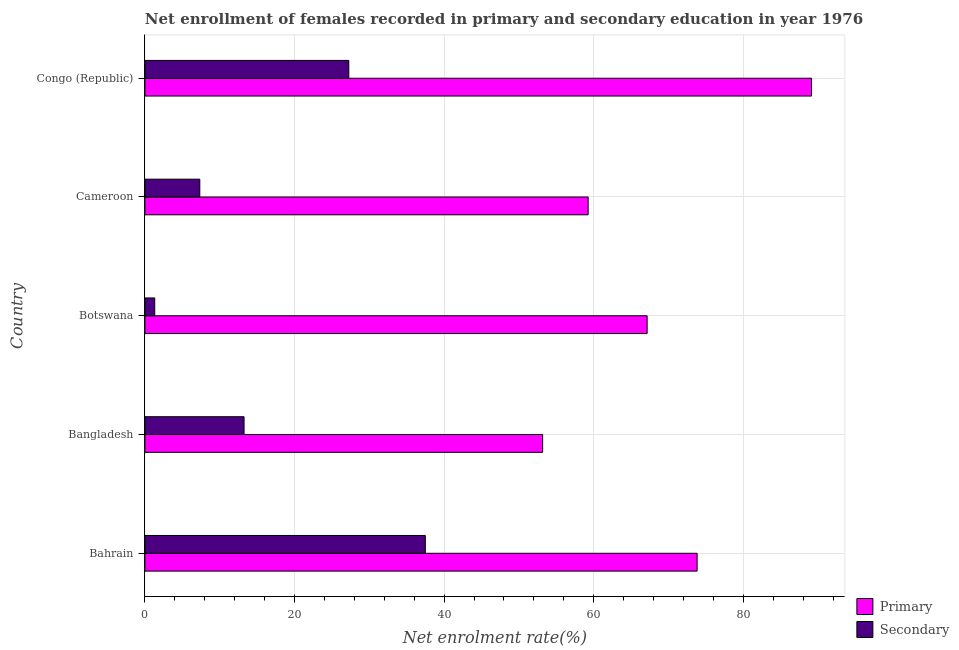How many groups of bars are there?
Offer a terse response. 5. How many bars are there on the 3rd tick from the top?
Your answer should be compact. 2. How many bars are there on the 4th tick from the bottom?
Your answer should be compact. 2. What is the label of the 4th group of bars from the top?
Offer a terse response. Bangladesh. What is the enrollment rate in primary education in Cameroon?
Offer a terse response. 59.25. Across all countries, what is the maximum enrollment rate in primary education?
Give a very brief answer. 89.11. Across all countries, what is the minimum enrollment rate in secondary education?
Offer a terse response. 1.31. In which country was the enrollment rate in secondary education maximum?
Offer a very short reply. Bahrain. In which country was the enrollment rate in secondary education minimum?
Offer a very short reply. Botswana. What is the total enrollment rate in secondary education in the graph?
Provide a succinct answer. 86.64. What is the difference between the enrollment rate in primary education in Bangladesh and that in Cameroon?
Provide a short and direct response. -6.08. What is the difference between the enrollment rate in primary education in Bangladesh and the enrollment rate in secondary education in Cameroon?
Make the answer very short. 45.83. What is the average enrollment rate in secondary education per country?
Keep it short and to the point. 17.33. What is the difference between the enrollment rate in secondary education and enrollment rate in primary education in Congo (Republic)?
Ensure brevity in your answer.  -61.86. In how many countries, is the enrollment rate in secondary education greater than 56 %?
Your answer should be very brief. 0. What is the ratio of the enrollment rate in primary education in Bahrain to that in Congo (Republic)?
Provide a succinct answer. 0.83. What is the difference between the highest and the second highest enrollment rate in secondary education?
Your answer should be very brief. 10.23. What is the difference between the highest and the lowest enrollment rate in primary education?
Make the answer very short. 35.95. In how many countries, is the enrollment rate in secondary education greater than the average enrollment rate in secondary education taken over all countries?
Your answer should be very brief. 2. Is the sum of the enrollment rate in primary education in Bahrain and Botswana greater than the maximum enrollment rate in secondary education across all countries?
Your answer should be very brief. Yes. What does the 1st bar from the top in Bangladesh represents?
Make the answer very short. Secondary. What does the 2nd bar from the bottom in Bahrain represents?
Your response must be concise. Secondary. How many bars are there?
Your answer should be compact. 10. How many countries are there in the graph?
Offer a very short reply. 5. What is the difference between two consecutive major ticks on the X-axis?
Your response must be concise. 20. Are the values on the major ticks of X-axis written in scientific E-notation?
Keep it short and to the point. No. Does the graph contain grids?
Your answer should be very brief. Yes. Where does the legend appear in the graph?
Give a very brief answer. Bottom right. How many legend labels are there?
Your answer should be very brief. 2. What is the title of the graph?
Keep it short and to the point. Net enrollment of females recorded in primary and secondary education in year 1976. Does "Drinking water services" appear as one of the legend labels in the graph?
Ensure brevity in your answer.  No. What is the label or title of the X-axis?
Offer a very short reply. Net enrolment rate(%). What is the label or title of the Y-axis?
Make the answer very short. Country. What is the Net enrolment rate(%) in Primary in Bahrain?
Offer a very short reply. 73.82. What is the Net enrolment rate(%) in Secondary in Bahrain?
Give a very brief answer. 37.48. What is the Net enrolment rate(%) of Primary in Bangladesh?
Your answer should be compact. 53.17. What is the Net enrolment rate(%) of Secondary in Bangladesh?
Ensure brevity in your answer.  13.25. What is the Net enrolment rate(%) of Primary in Botswana?
Offer a terse response. 67.14. What is the Net enrolment rate(%) in Secondary in Botswana?
Provide a short and direct response. 1.31. What is the Net enrolment rate(%) in Primary in Cameroon?
Your response must be concise. 59.25. What is the Net enrolment rate(%) of Secondary in Cameroon?
Your answer should be very brief. 7.34. What is the Net enrolment rate(%) of Primary in Congo (Republic)?
Your answer should be very brief. 89.11. What is the Net enrolment rate(%) in Secondary in Congo (Republic)?
Provide a succinct answer. 27.25. Across all countries, what is the maximum Net enrolment rate(%) of Primary?
Ensure brevity in your answer.  89.11. Across all countries, what is the maximum Net enrolment rate(%) in Secondary?
Make the answer very short. 37.48. Across all countries, what is the minimum Net enrolment rate(%) in Primary?
Give a very brief answer. 53.17. Across all countries, what is the minimum Net enrolment rate(%) of Secondary?
Make the answer very short. 1.31. What is the total Net enrolment rate(%) of Primary in the graph?
Your answer should be compact. 342.48. What is the total Net enrolment rate(%) of Secondary in the graph?
Your response must be concise. 86.64. What is the difference between the Net enrolment rate(%) in Primary in Bahrain and that in Bangladesh?
Offer a very short reply. 20.65. What is the difference between the Net enrolment rate(%) in Secondary in Bahrain and that in Bangladesh?
Provide a succinct answer. 24.23. What is the difference between the Net enrolment rate(%) of Primary in Bahrain and that in Botswana?
Make the answer very short. 6.68. What is the difference between the Net enrolment rate(%) of Secondary in Bahrain and that in Botswana?
Your answer should be very brief. 36.17. What is the difference between the Net enrolment rate(%) in Primary in Bahrain and that in Cameroon?
Keep it short and to the point. 14.57. What is the difference between the Net enrolment rate(%) of Secondary in Bahrain and that in Cameroon?
Your answer should be compact. 30.15. What is the difference between the Net enrolment rate(%) of Primary in Bahrain and that in Congo (Republic)?
Keep it short and to the point. -15.29. What is the difference between the Net enrolment rate(%) in Secondary in Bahrain and that in Congo (Republic)?
Ensure brevity in your answer.  10.23. What is the difference between the Net enrolment rate(%) of Primary in Bangladesh and that in Botswana?
Offer a terse response. -13.97. What is the difference between the Net enrolment rate(%) of Secondary in Bangladesh and that in Botswana?
Offer a terse response. 11.94. What is the difference between the Net enrolment rate(%) in Primary in Bangladesh and that in Cameroon?
Ensure brevity in your answer.  -6.08. What is the difference between the Net enrolment rate(%) of Secondary in Bangladesh and that in Cameroon?
Keep it short and to the point. 5.92. What is the difference between the Net enrolment rate(%) of Primary in Bangladesh and that in Congo (Republic)?
Give a very brief answer. -35.95. What is the difference between the Net enrolment rate(%) in Secondary in Bangladesh and that in Congo (Republic)?
Offer a very short reply. -14. What is the difference between the Net enrolment rate(%) in Primary in Botswana and that in Cameroon?
Your answer should be compact. 7.88. What is the difference between the Net enrolment rate(%) in Secondary in Botswana and that in Cameroon?
Make the answer very short. -6.03. What is the difference between the Net enrolment rate(%) in Primary in Botswana and that in Congo (Republic)?
Give a very brief answer. -21.98. What is the difference between the Net enrolment rate(%) in Secondary in Botswana and that in Congo (Republic)?
Offer a very short reply. -25.94. What is the difference between the Net enrolment rate(%) in Primary in Cameroon and that in Congo (Republic)?
Your answer should be very brief. -29.86. What is the difference between the Net enrolment rate(%) in Secondary in Cameroon and that in Congo (Republic)?
Offer a very short reply. -19.92. What is the difference between the Net enrolment rate(%) of Primary in Bahrain and the Net enrolment rate(%) of Secondary in Bangladesh?
Keep it short and to the point. 60.57. What is the difference between the Net enrolment rate(%) of Primary in Bahrain and the Net enrolment rate(%) of Secondary in Botswana?
Ensure brevity in your answer.  72.51. What is the difference between the Net enrolment rate(%) of Primary in Bahrain and the Net enrolment rate(%) of Secondary in Cameroon?
Give a very brief answer. 66.48. What is the difference between the Net enrolment rate(%) in Primary in Bahrain and the Net enrolment rate(%) in Secondary in Congo (Republic)?
Keep it short and to the point. 46.56. What is the difference between the Net enrolment rate(%) in Primary in Bangladesh and the Net enrolment rate(%) in Secondary in Botswana?
Provide a short and direct response. 51.85. What is the difference between the Net enrolment rate(%) in Primary in Bangladesh and the Net enrolment rate(%) in Secondary in Cameroon?
Ensure brevity in your answer.  45.83. What is the difference between the Net enrolment rate(%) of Primary in Bangladesh and the Net enrolment rate(%) of Secondary in Congo (Republic)?
Your response must be concise. 25.91. What is the difference between the Net enrolment rate(%) in Primary in Botswana and the Net enrolment rate(%) in Secondary in Cameroon?
Your answer should be compact. 59.8. What is the difference between the Net enrolment rate(%) in Primary in Botswana and the Net enrolment rate(%) in Secondary in Congo (Republic)?
Ensure brevity in your answer.  39.88. What is the difference between the Net enrolment rate(%) in Primary in Cameroon and the Net enrolment rate(%) in Secondary in Congo (Republic)?
Keep it short and to the point. 32. What is the average Net enrolment rate(%) in Primary per country?
Make the answer very short. 68.5. What is the average Net enrolment rate(%) in Secondary per country?
Provide a succinct answer. 17.33. What is the difference between the Net enrolment rate(%) of Primary and Net enrolment rate(%) of Secondary in Bahrain?
Your answer should be very brief. 36.33. What is the difference between the Net enrolment rate(%) in Primary and Net enrolment rate(%) in Secondary in Bangladesh?
Your answer should be compact. 39.91. What is the difference between the Net enrolment rate(%) in Primary and Net enrolment rate(%) in Secondary in Botswana?
Your answer should be compact. 65.82. What is the difference between the Net enrolment rate(%) of Primary and Net enrolment rate(%) of Secondary in Cameroon?
Offer a very short reply. 51.91. What is the difference between the Net enrolment rate(%) in Primary and Net enrolment rate(%) in Secondary in Congo (Republic)?
Give a very brief answer. 61.86. What is the ratio of the Net enrolment rate(%) in Primary in Bahrain to that in Bangladesh?
Make the answer very short. 1.39. What is the ratio of the Net enrolment rate(%) of Secondary in Bahrain to that in Bangladesh?
Offer a very short reply. 2.83. What is the ratio of the Net enrolment rate(%) in Primary in Bahrain to that in Botswana?
Make the answer very short. 1.1. What is the ratio of the Net enrolment rate(%) in Secondary in Bahrain to that in Botswana?
Make the answer very short. 28.58. What is the ratio of the Net enrolment rate(%) in Primary in Bahrain to that in Cameroon?
Keep it short and to the point. 1.25. What is the ratio of the Net enrolment rate(%) of Secondary in Bahrain to that in Cameroon?
Give a very brief answer. 5.11. What is the ratio of the Net enrolment rate(%) of Primary in Bahrain to that in Congo (Republic)?
Your answer should be very brief. 0.83. What is the ratio of the Net enrolment rate(%) of Secondary in Bahrain to that in Congo (Republic)?
Your answer should be very brief. 1.38. What is the ratio of the Net enrolment rate(%) in Primary in Bangladesh to that in Botswana?
Keep it short and to the point. 0.79. What is the ratio of the Net enrolment rate(%) of Secondary in Bangladesh to that in Botswana?
Your answer should be very brief. 10.1. What is the ratio of the Net enrolment rate(%) of Primary in Bangladesh to that in Cameroon?
Offer a very short reply. 0.9. What is the ratio of the Net enrolment rate(%) of Secondary in Bangladesh to that in Cameroon?
Make the answer very short. 1.81. What is the ratio of the Net enrolment rate(%) of Primary in Bangladesh to that in Congo (Republic)?
Your answer should be very brief. 0.6. What is the ratio of the Net enrolment rate(%) of Secondary in Bangladesh to that in Congo (Republic)?
Make the answer very short. 0.49. What is the ratio of the Net enrolment rate(%) in Primary in Botswana to that in Cameroon?
Provide a succinct answer. 1.13. What is the ratio of the Net enrolment rate(%) in Secondary in Botswana to that in Cameroon?
Provide a succinct answer. 0.18. What is the ratio of the Net enrolment rate(%) of Primary in Botswana to that in Congo (Republic)?
Your answer should be very brief. 0.75. What is the ratio of the Net enrolment rate(%) of Secondary in Botswana to that in Congo (Republic)?
Make the answer very short. 0.05. What is the ratio of the Net enrolment rate(%) in Primary in Cameroon to that in Congo (Republic)?
Offer a terse response. 0.66. What is the ratio of the Net enrolment rate(%) of Secondary in Cameroon to that in Congo (Republic)?
Keep it short and to the point. 0.27. What is the difference between the highest and the second highest Net enrolment rate(%) in Primary?
Your answer should be very brief. 15.29. What is the difference between the highest and the second highest Net enrolment rate(%) in Secondary?
Give a very brief answer. 10.23. What is the difference between the highest and the lowest Net enrolment rate(%) of Primary?
Keep it short and to the point. 35.95. What is the difference between the highest and the lowest Net enrolment rate(%) of Secondary?
Your answer should be compact. 36.17. 